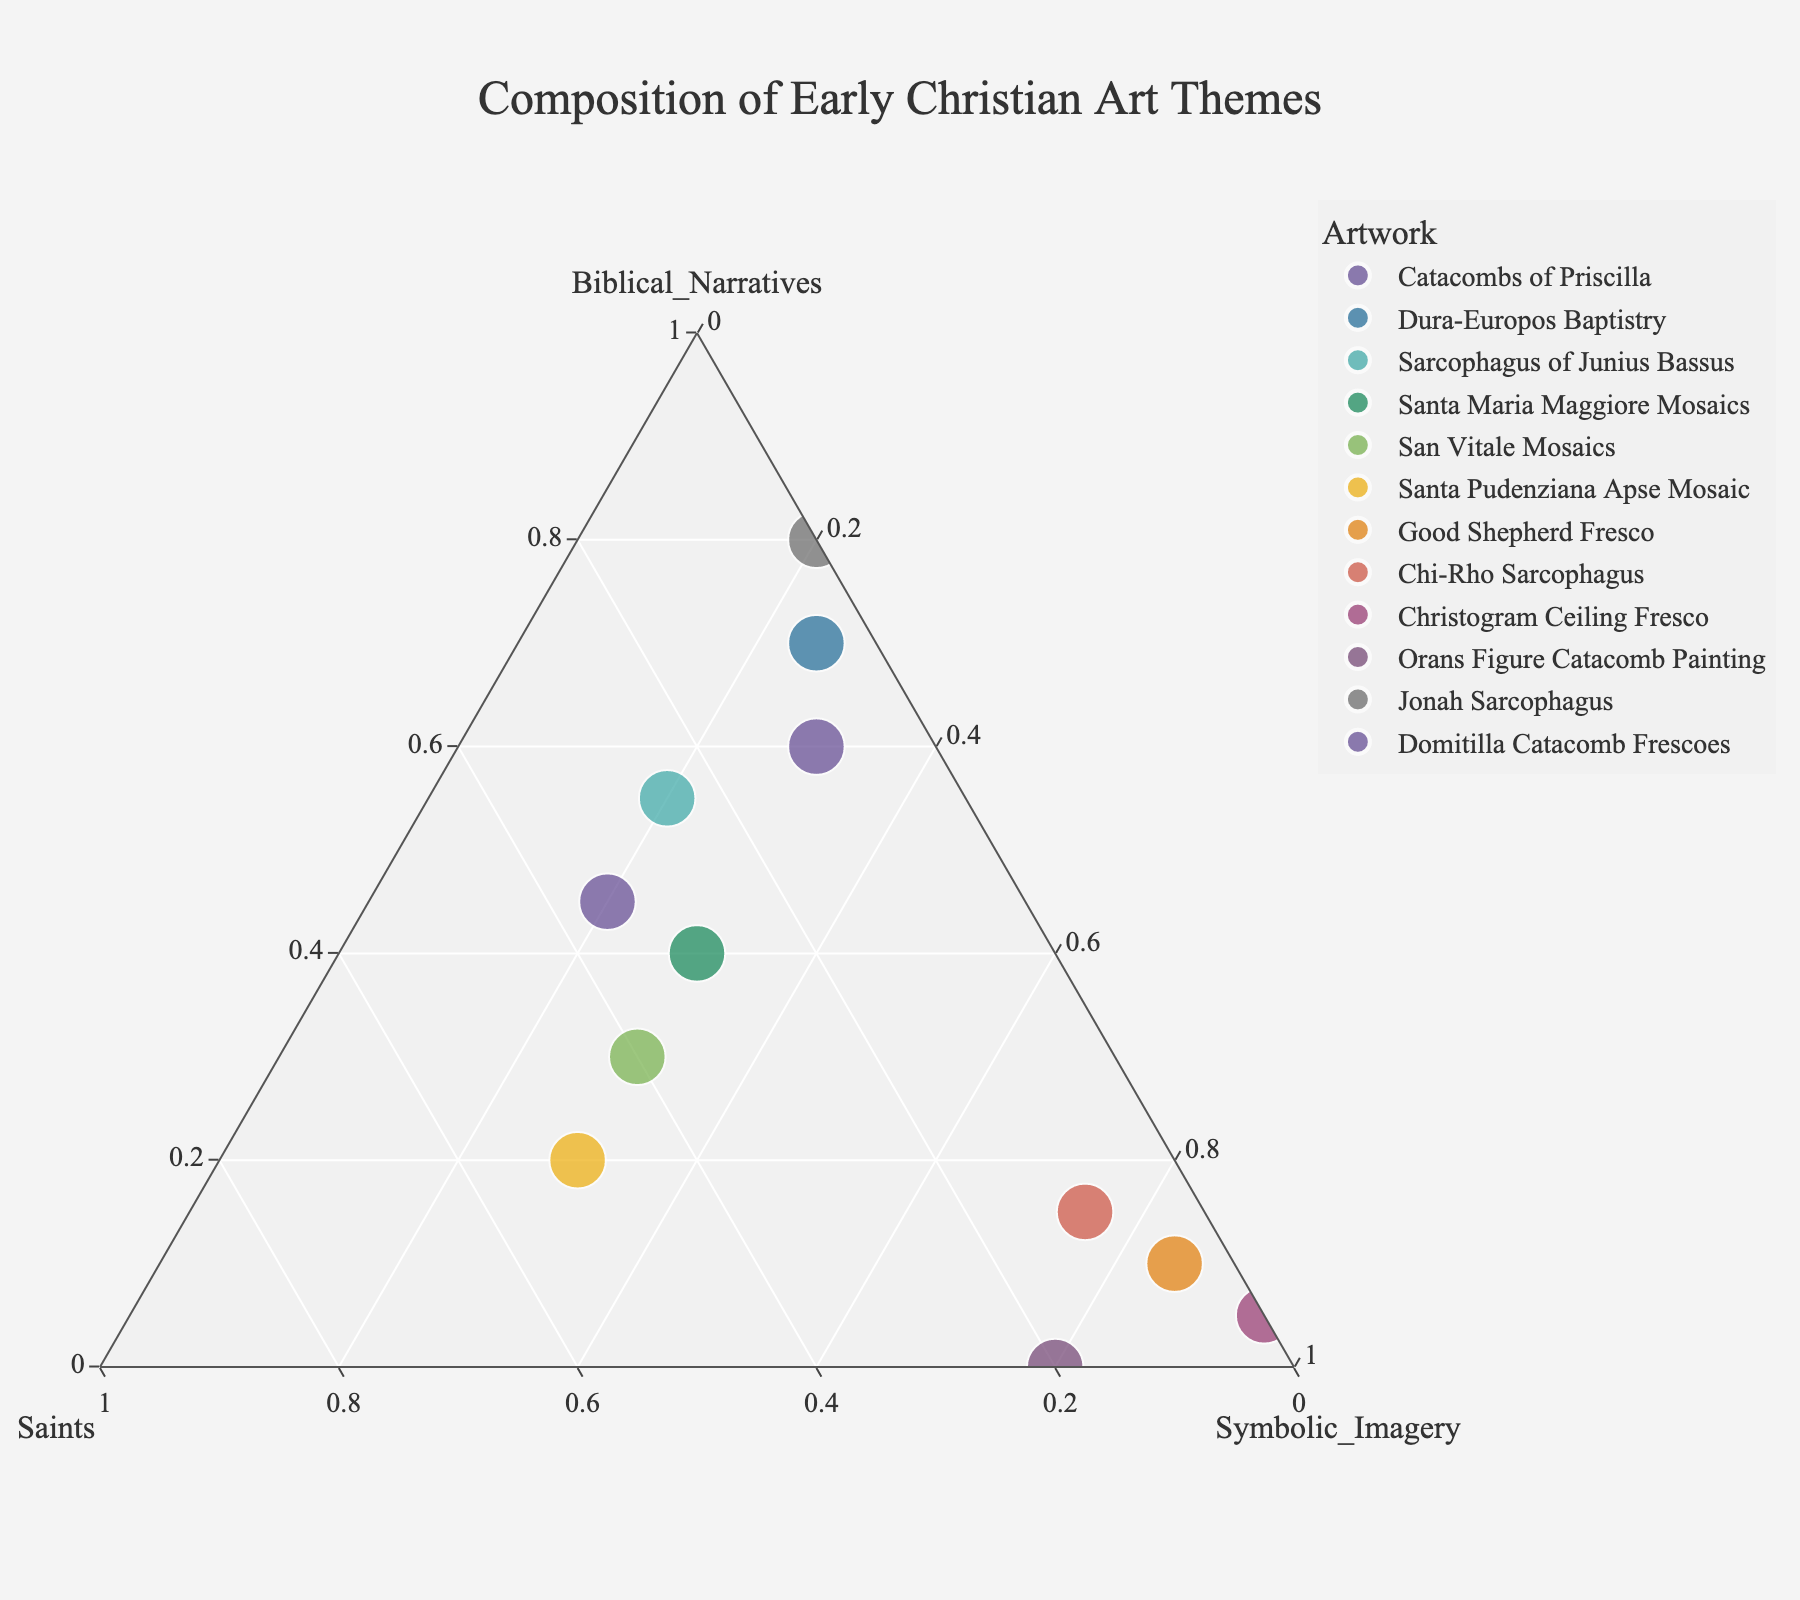How many artworks in the figure have more than 50% of Biblical Narratives? To find this, count the data points where the "Biblical Narratives" value is greater than 50%. Those are the Catacombs of Priscilla, Dura-Europos Baptistry, Jonah Sarcophagus, and Sarcophagus of Junius Bassus.
Answer: 4 Which artwork has the highest percentage of Symbolic Imagery? Look at each data point and identify which one has the highest value for "Symbolic Imagery," which is the Christogram Ceiling Fresco with 95%.
Answer: Christogram Ceiling Fresco Are there any artworks that have an equal distribution of Saints and Symbolic Imagery? Check if there are any data points where the percentages for "Saints" and "Symbolic Imagery" are the same. Santa Maria Maggiore Mosaics and San Vitale Mosaics both have equal percentages for these themes, 30%.
Answer: Santa Maria Maggiore Mosaics, San Vitale Mosaics Which artwork focuses primarily on Saints? Find the data point with the highest percentage in the "Saints" category. The Santa Pudenziana Apse Mosaic has the highest at 50%.
Answer: Santa Pudenziana Apse Mosaic What's the total percentage of Symbolic Imagery for the Good Shepherd Fresco and Orans Figure Catacomb Painting together? Add the Symbolic Imagery percentages for both artworks: 85% + 80% = 165%.
Answer: 165% Which has a greater percentage of Saints: Domitilla Catacomb Frescoes or Chi-Rho Sarcophagus? Compare the "Saints" values for the Domitilla Catacomb Frescoes (35%) and Chi-Rho Sarcophagus (10%). 35% is greater than 10%.
Answer: Domitilla Catacomb Frescoes Is there any artwork depicted with no Saints? If yes, name it. Check each data point for the "Saints" value of 0%. The Jonah Sarcophagus and Christogram Ceiling Fresco have 0% Saints.
Answer: Jonah Sarcophagus, Christogram Ceiling Fresco Which artwork has the lowest percentage of Biblical Narratives? Identify the data point with the lowest "Biblical Narratives" value. The Christogram Ceiling Fresco has the lowest percentage at 5%.
Answer: Christogram Ceiling Fresco Which artwork has a balanced representation of all three themes? Check for the data point where the values of "Biblical Narratives," "Saints," and "Symbolic Imagery" are as close as possible. The Santa Maria Maggiore Mosaics have 40%, 30%, and 30%, respectively.
Answer: Santa Maria Maggiore Mosaics 